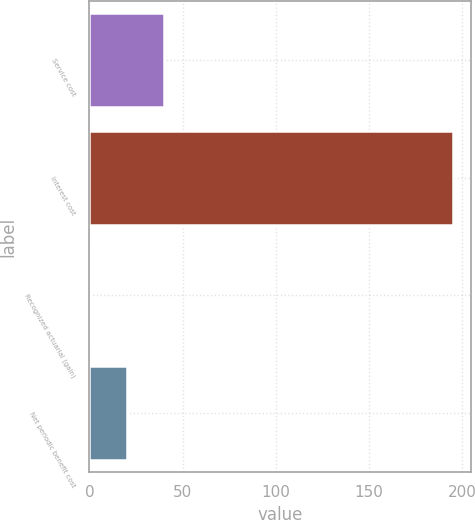<chart> <loc_0><loc_0><loc_500><loc_500><bar_chart><fcel>Service cost<fcel>Interest cost<fcel>Recognized actuarial (gain)<fcel>Net periodic benefit cost<nl><fcel>39.8<fcel>195<fcel>1<fcel>20.4<nl></chart> 